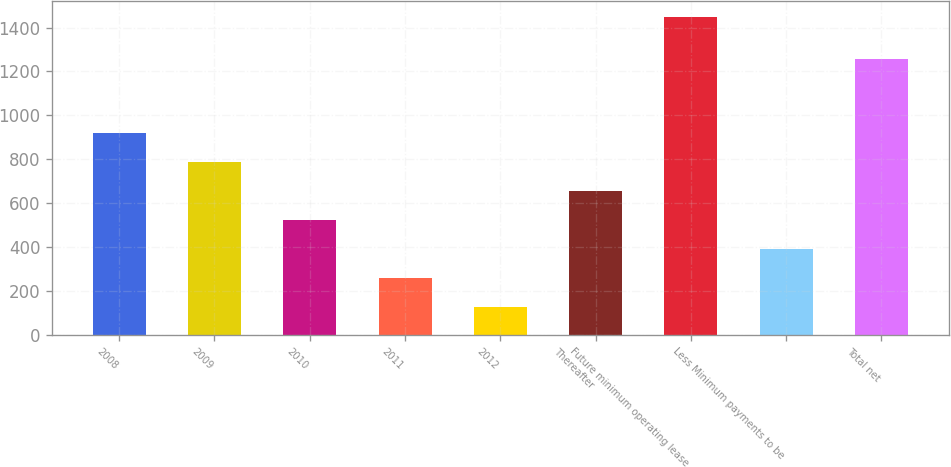Convert chart. <chart><loc_0><loc_0><loc_500><loc_500><bar_chart><fcel>2008<fcel>2009<fcel>2010<fcel>2011<fcel>2012<fcel>Thereafter<fcel>Future minimum operating lease<fcel>Less Minimum payments to be<fcel>Total net<nl><fcel>918.4<fcel>786<fcel>521.2<fcel>256.4<fcel>124<fcel>653.6<fcel>1448<fcel>388.8<fcel>1258<nl></chart> 